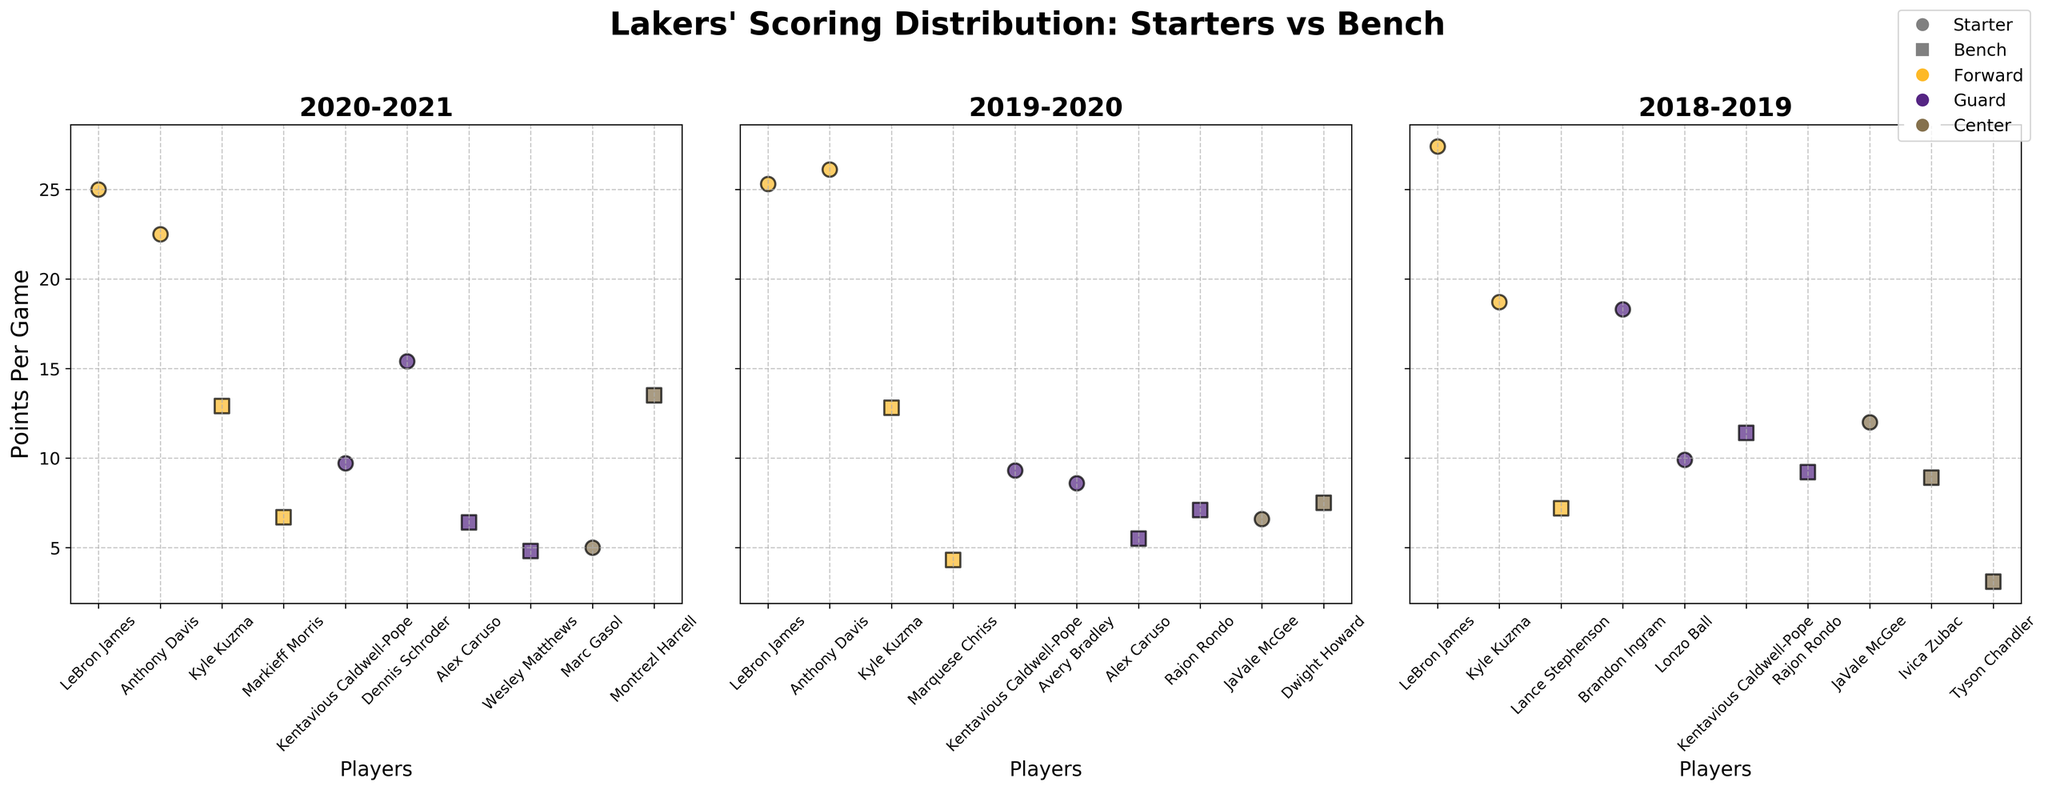What's the title of the figure? The title of a figure is usually found at the top in bold text. In this figure, it reads "Lakers' Scoring Distribution: Starters vs Bench".
Answer: "Lakers' Scoring Distribution: Starters vs Bench" How many seasons are displayed in the figure? Check for the individual subplots within the figure; each subplot represents a different season. Count these subplots to determine the number of seasons.
Answer: 3 seasons In the 2020-2021 season, which player had the highest points per game among the starters? Look at the points per game values for each starter in the 2020-2021 subplot and identify the highest one. LeBron James with 25.0 points per game stands out among the starters.
Answer: LeBron James What's the average points per game of the bench players in the 2019-2020 season? Identify the bench players in the 2019-2020 subplot and sum their points per game. Divide the sum by the number of bench players to get the average. The bench players' points per game are (12.8, 7.5, 5.5, 7.1, 4.3). Sum = 37.2, Average = 37.2/5 = 7.44
Answer: 7.44 Compare the points per game of LeBron James and Anthony Davis in the 2019-2020 season. Who scored more? Look at the points per game for LeBron James and Anthony Davis in the 2019-2020 subplot. LeBron had 25.3, Anthony Davis had 26.1. Anthony Davis scored more.
Answer: Anthony Davis Which position had the least points per game among the bench players in the 2018-2019 season? Examine the 2018-2019 subplot for the bench players. Compare their points per game. Tyson Chandler, a Center, had the least with 3.1 points per game.
Answer: Center Who was the highest-scoring guard among the starters across all seasons? Scan each subplot and identify the guards' points per game among the starters. Brandon Ingram in the 2018-2019 season had 18.3 points per game, which is the highest among the guards.
Answer: Brandon Ingram What is the median points per game for all bench players in the 2020-2021 season? List the points per game of bench players (12.9, 13.5, 6.4, 4.8, 6.7). Sort them (4.8, 6.4, 6.7, 12.9, 13.5). The median value is the middle one: 6.7.
Answer: 6.7 In the 2018-2019 season, were there more players scoring above or below 10 points per game? Categorize the players in the 2018-2019 subplot by their points per game: above 10 (LeBron James, Kyle Kuzma, Brandon Ingram, JaVale McGee, Kentavious Caldwell-Pope), and below 10 (Lonzo Ball, Rajon Rondo, Lance Stephenson, Ivica Zubac, Tyson Chandler). There are more players below 10 points per game.
Answer: Below 